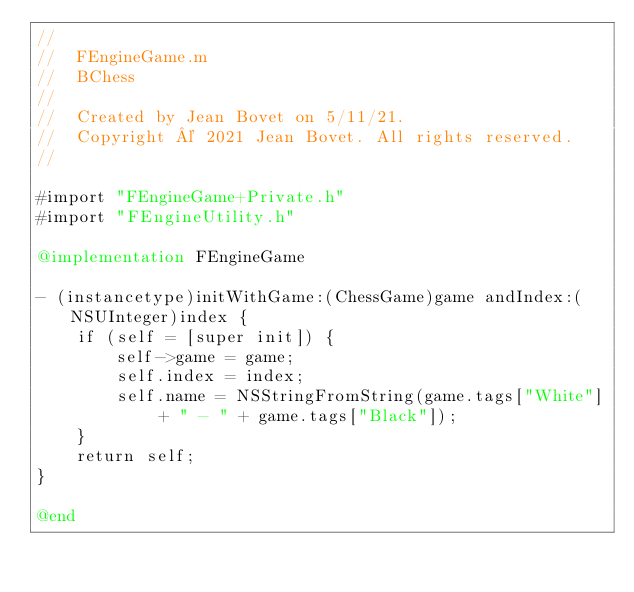Convert code to text. <code><loc_0><loc_0><loc_500><loc_500><_ObjectiveC_>//
//  FEngineGame.m
//  BChess
//
//  Created by Jean Bovet on 5/11/21.
//  Copyright © 2021 Jean Bovet. All rights reserved.
//

#import "FEngineGame+Private.h"
#import "FEngineUtility.h"

@implementation FEngineGame

- (instancetype)initWithGame:(ChessGame)game andIndex:(NSUInteger)index {
    if (self = [super init]) {
        self->game = game;
        self.index = index;
        self.name = NSStringFromString(game.tags["White"] + " - " + game.tags["Black"]);
    }
    return self;
}

@end
</code> 